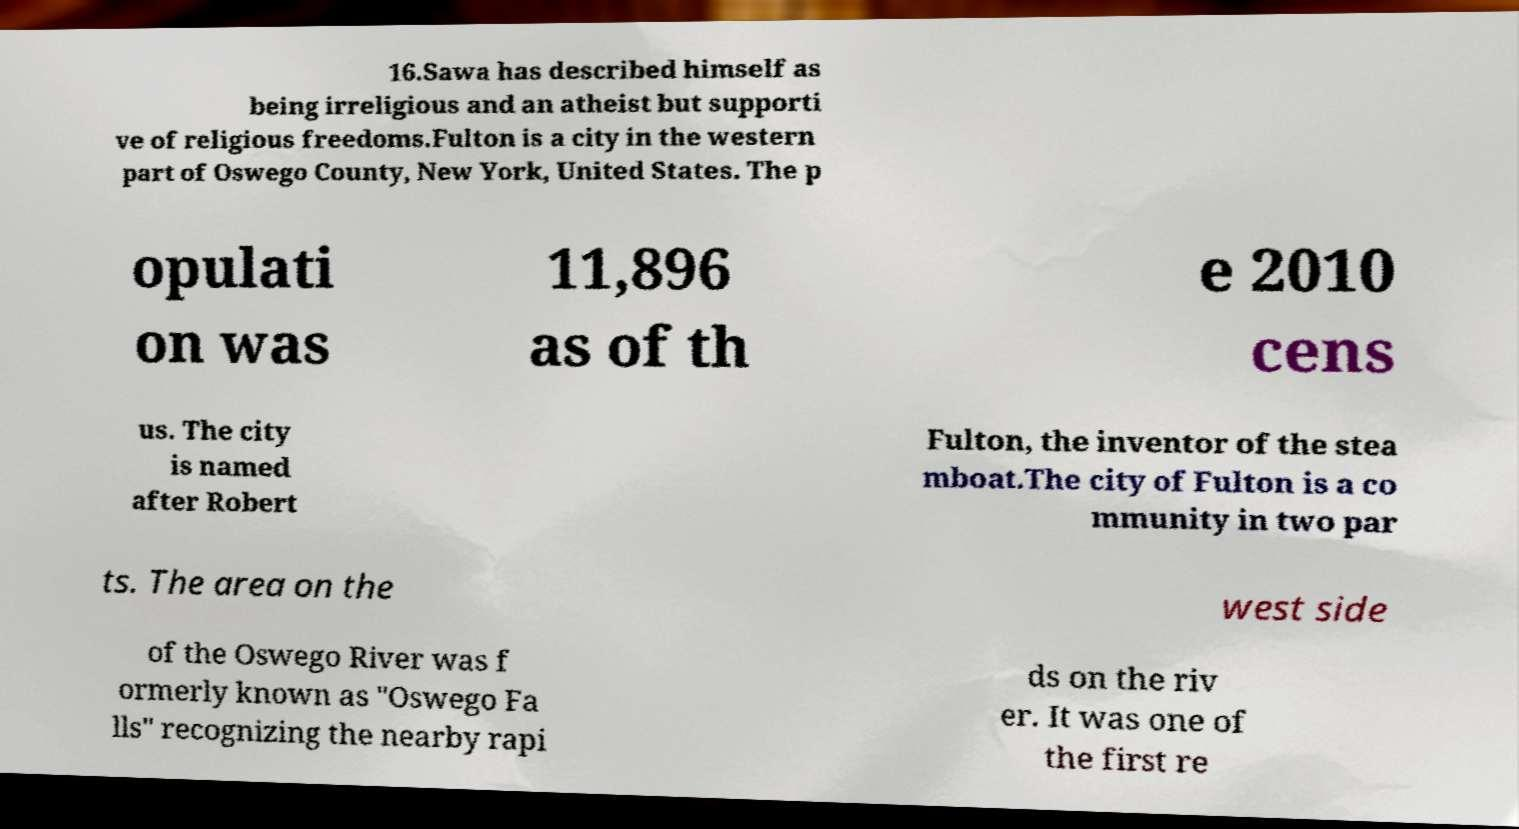Could you assist in decoding the text presented in this image and type it out clearly? 16.Sawa has described himself as being irreligious and an atheist but supporti ve of religious freedoms.Fulton is a city in the western part of Oswego County, New York, United States. The p opulati on was 11,896 as of th e 2010 cens us. The city is named after Robert Fulton, the inventor of the stea mboat.The city of Fulton is a co mmunity in two par ts. The area on the west side of the Oswego River was f ormerly known as "Oswego Fa lls" recognizing the nearby rapi ds on the riv er. It was one of the first re 